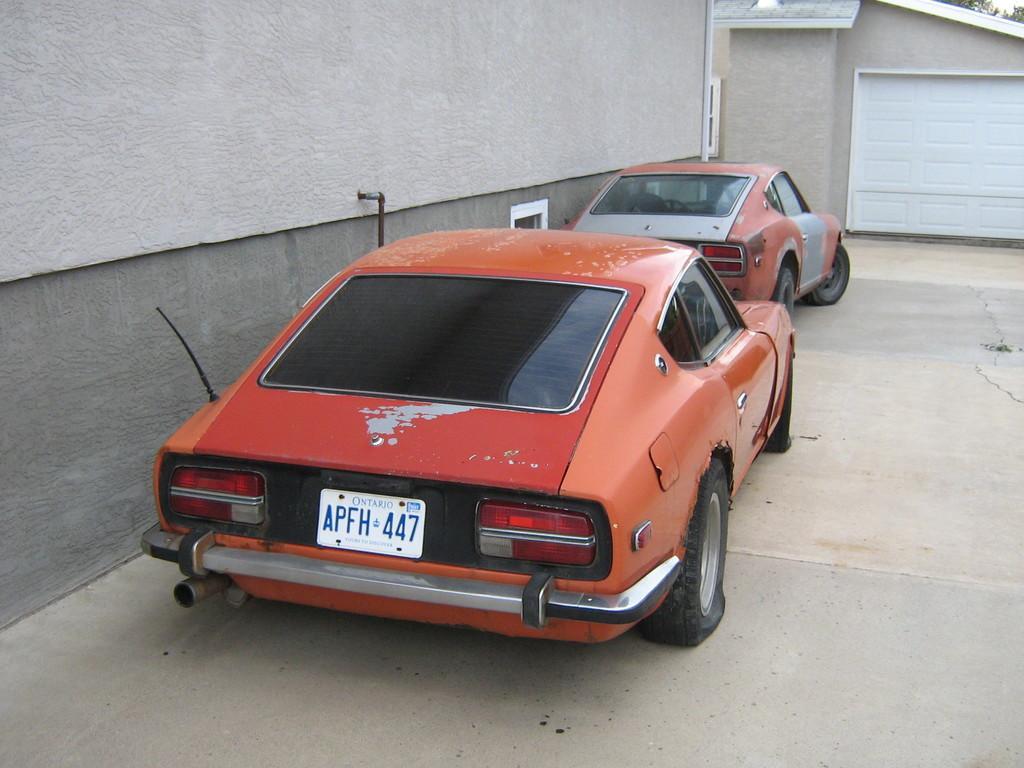Can you describe this image briefly? In this picture, we see two red cars are parked on the road. Beside that, we see a wall. In the background, we see a wall and something in white color. In the right top of the picture, we see the trees. 